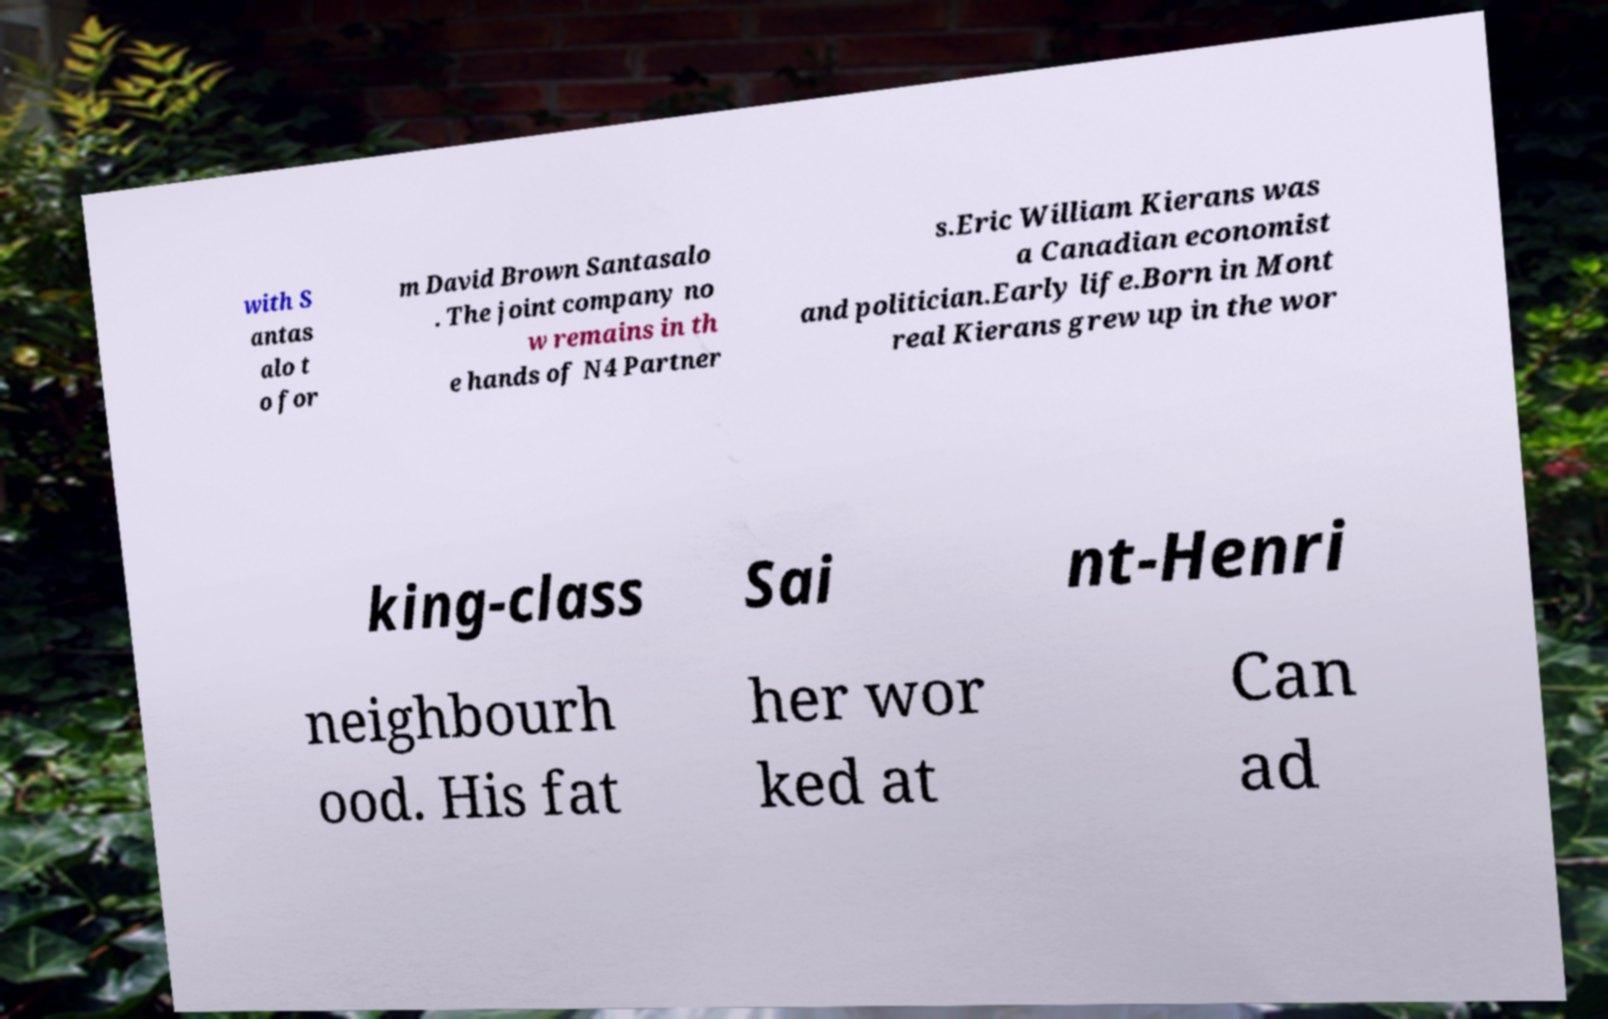Could you extract and type out the text from this image? with S antas alo t o for m David Brown Santasalo . The joint company no w remains in th e hands of N4 Partner s.Eric William Kierans was a Canadian economist and politician.Early life.Born in Mont real Kierans grew up in the wor king-class Sai nt-Henri neighbourh ood. His fat her wor ked at Can ad 